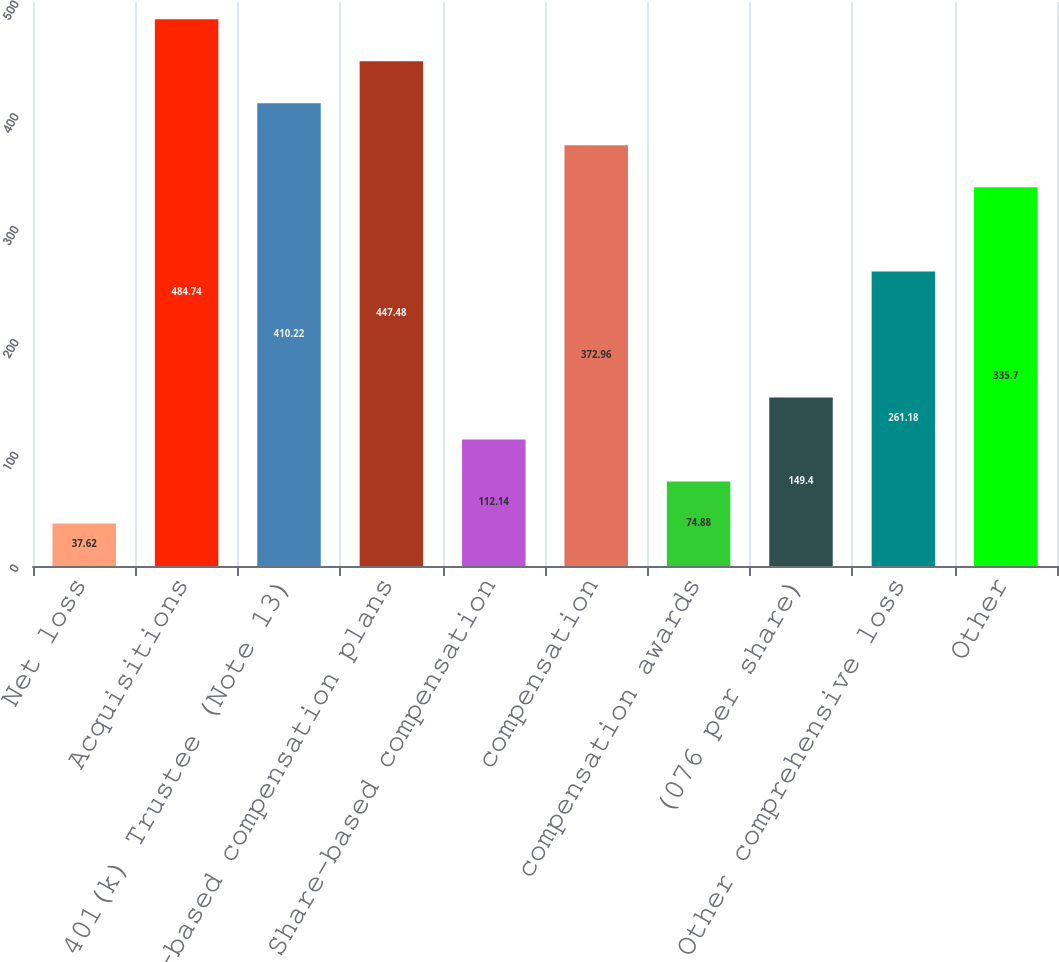Convert chart. <chart><loc_0><loc_0><loc_500><loc_500><bar_chart><fcel>Net loss<fcel>Acquisitions<fcel>401(k) Trustee (Note 13)<fcel>Share-based compensation plans<fcel>Share-based compensation<fcel>compensation<fcel>compensation awards<fcel>(076 per share)<fcel>Other comprehensive loss<fcel>Other<nl><fcel>37.62<fcel>484.74<fcel>410.22<fcel>447.48<fcel>112.14<fcel>372.96<fcel>74.88<fcel>149.4<fcel>261.18<fcel>335.7<nl></chart> 